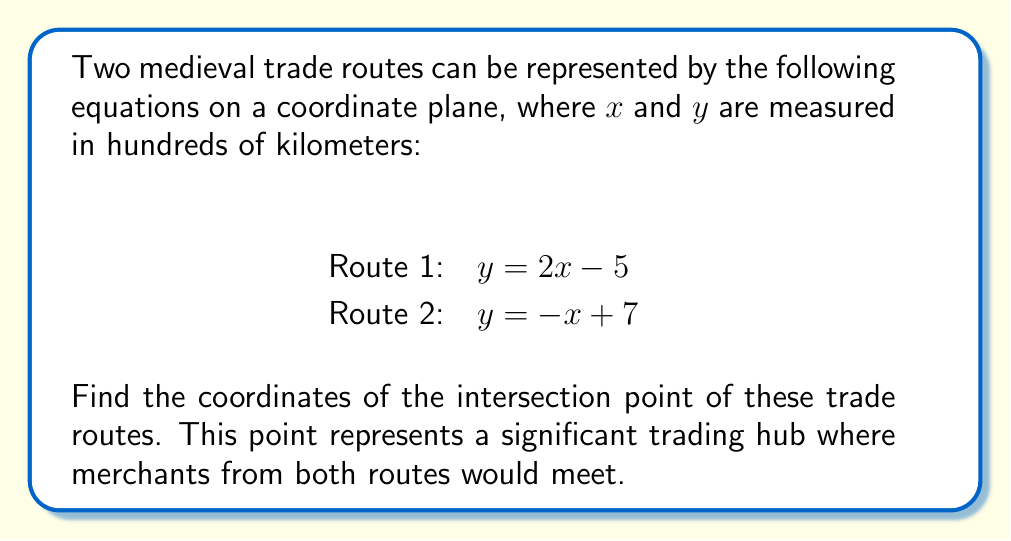Give your solution to this math problem. To find the intersection point of the two trade routes, we need to solve the system of equations:

$$\begin{cases}
y = 2x - 5 \\
y = -x + 7
\end{cases}$$

Step 1: Set the equations equal to each other since they represent the same y-coordinate at the intersection point.
$2x - 5 = -x + 7$

Step 2: Solve for x by adding x to both sides and adding 5 to both sides.
$3x = 12$
$x = 4$

Step 3: Substitute x = 4 into either of the original equations to find y. Let's use the first equation:
$y = 2(4) - 5 = 8 - 5 = 3$

Step 4: Express the solution as an ordered pair (x, y).
The intersection point is (4, 3).

Step 5: Interpret the result in the context of the problem.
The trade routes intersect at the point (4, 3), which represents 400 km east and 300 km north of the origin on our coordinate system.

[asy]
unitsize(1cm);
import graph;

xlimits(-1, 6);
ylimits(-1, 6);

xaxis("x", arrow=Arrow);
yaxis("y", arrow=Arrow);

draw((0,5)--(5,15), blue);
draw((0,7)--(7,0), red);

dot((4,3), p=black);
label("(4, 3)", (4,3), NE);

label("Route 1", (5,15), E, blue);
label("Route 2", (7,0), SE, red);
[/asy]
Answer: (4, 3) 